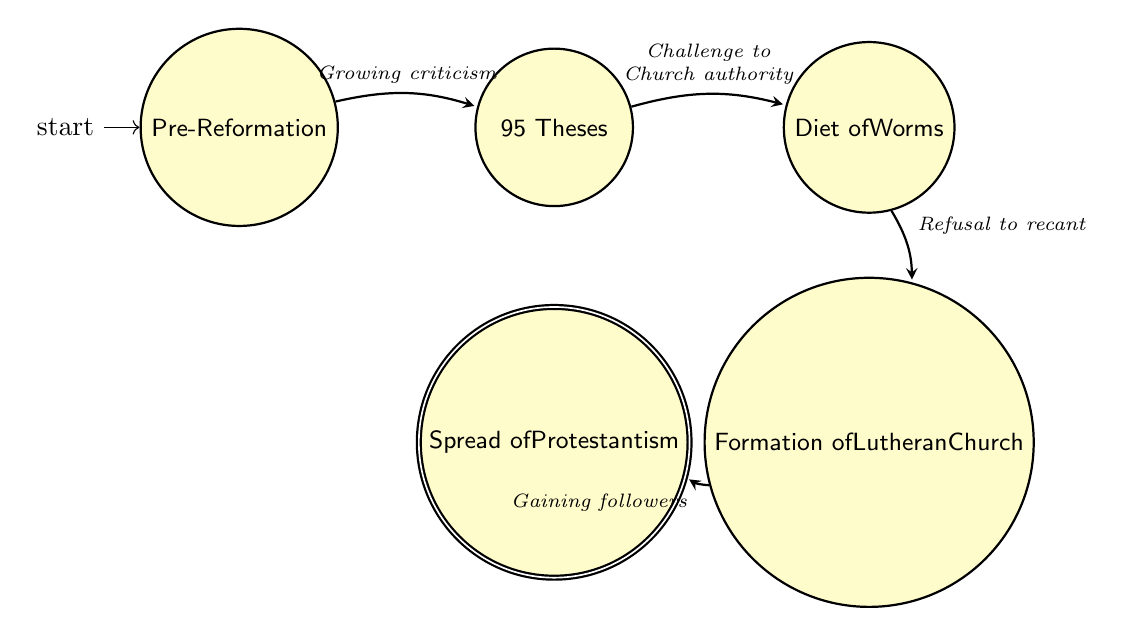What is the first state in the diagram? The first state is indicated as the starting point in the diagram, labeled "Pre-Reformation."
Answer: Pre-Reformation How many total states are in the diagram? To find the total number of states, count the distinct states represented, which includes "Pre-Reformation," "95 Theses," "Diet of Worms," "Formation of Lutheran Church," and "Spread of Protestantism." This gives a total of five states.
Answer: 5 What event leads from "95 Theses" to "Diet of Worms"? The arrow labeled "Challenge to Church authority" between the nodes indicates this transition, representing the event that follows "95 Theses."
Answer: Challenge to Church authority What is the final state of the sequence? The final state is the last node reached in the diagram, indicated as "Spread of Protestantism."
Answer: Spread of Protestantism What transition occurs after "Diet of Worms"? The transition leading from "Diet of Worms" is labeled "Refusal to recant," showing the action taken by Luther following that event.
Answer: Refusal to recant Which state represents the establishment of a distinct church? The state that signifies the creation of a distinct church is "Formation of Lutheran Church."
Answer: Formation of Lutheran Church How does the "Formation of Lutheran Church" state connect to the wider movement? The connection is indicated by the transition labeled "Gaining followers," which shows how the formation of the church leads to a broader movement.
Answer: Gaining followers What state represents the period before the Protestant Reformation? The state that corresponds to the time before the significant events of the Reformation is labeled "Pre-Reformation."
Answer: Pre-Reformation Which two states are directly linked by the transition "Growing criticism"? The transition "Growing criticism" connects "Pre-Reformation" to "95 Theses," indicating the progression from dissatisfaction to action.
Answer: Pre-Reformation and 95 Theses 